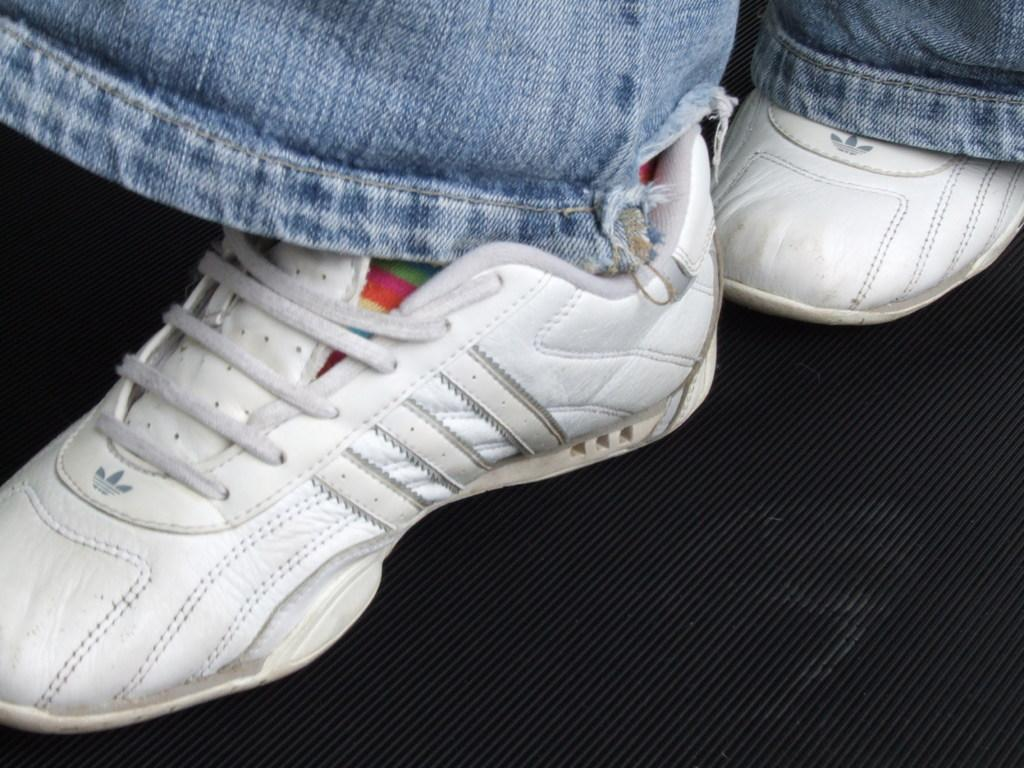What body part is visible in the image? There are legs visible in the image. What type of footwear is the person wearing? The person is wearing shoes. What type of mitten is the scarecrow holding in the image? There is no scarecrow or mitten present in the image. What type of conversation is the person having with the talk show host in the image? There is no talk show host or conversation present in the image. 